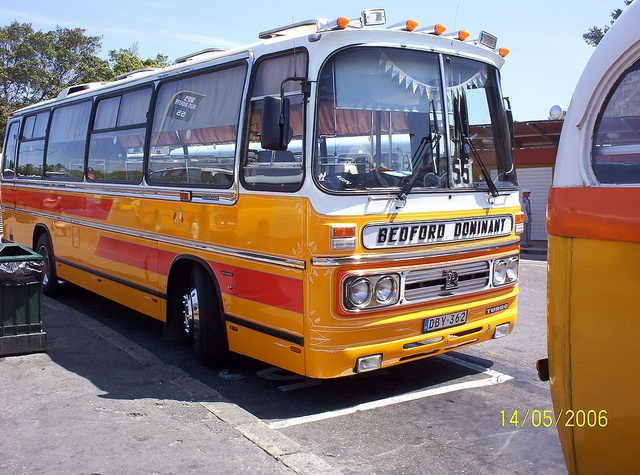Describe the objects in this image and their specific colors. I can see bus in lightblue, black, red, and gray tones, bus in lightblue, brown, lavender, and maroon tones, and people in lightblue, purple, gray, and black tones in this image. 